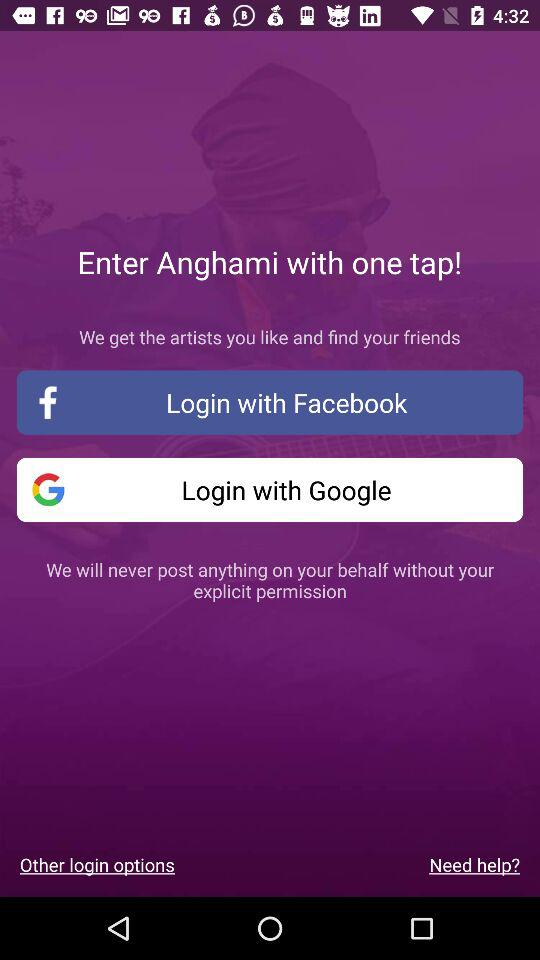What accounts can I use to sign up? You can use a "Facebook" or "Google" account to sign up. 